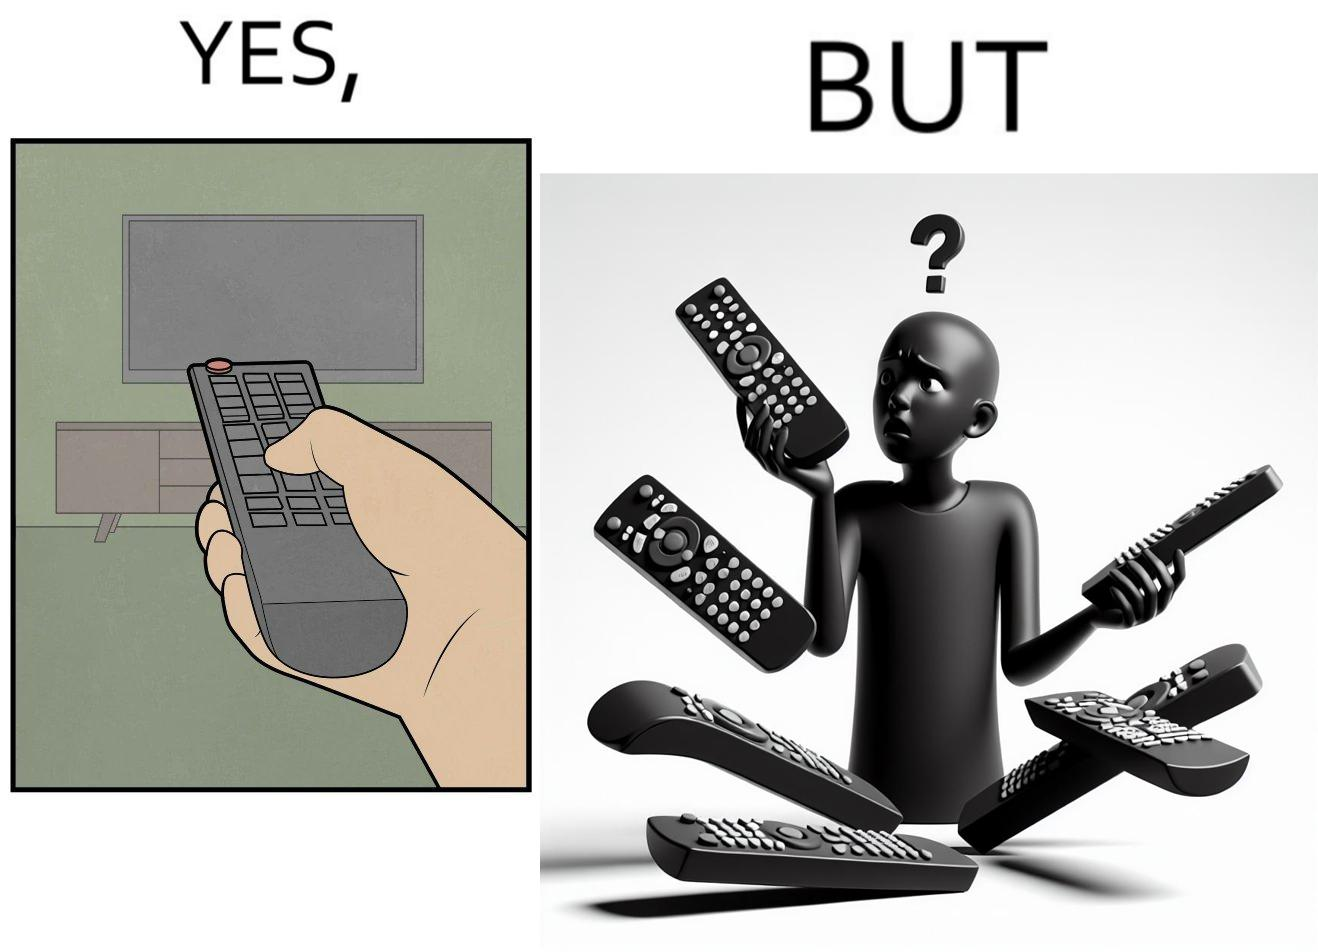Describe the contrast between the left and right parts of this image. In the left part of the image: It is a remote being used to operate a TV In the right part of the image: It is an user confused between multiple remotes 